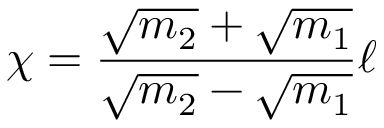<formula> <loc_0><loc_0><loc_500><loc_500>\chi = \frac { \sqrt { m _ { 2 } } + \sqrt { m _ { 1 } } } { \sqrt { m _ { 2 } } - \sqrt { m _ { 1 } } } \ell</formula> 